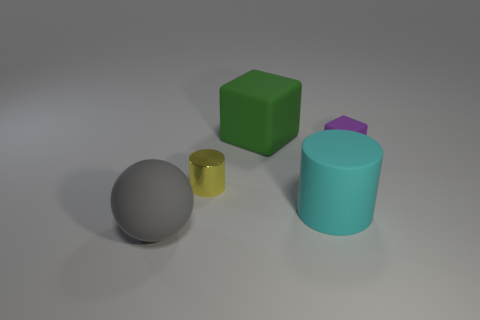Add 5 large gray matte objects. How many objects exist? 10 Subtract all yellow balls. Subtract all green blocks. How many balls are left? 1 Subtract all cylinders. How many objects are left? 3 Subtract all large cyan things. Subtract all tiny cyan things. How many objects are left? 4 Add 3 tiny metal cylinders. How many tiny metal cylinders are left? 4 Add 3 brown rubber cylinders. How many brown rubber cylinders exist? 3 Subtract 0 red cylinders. How many objects are left? 5 